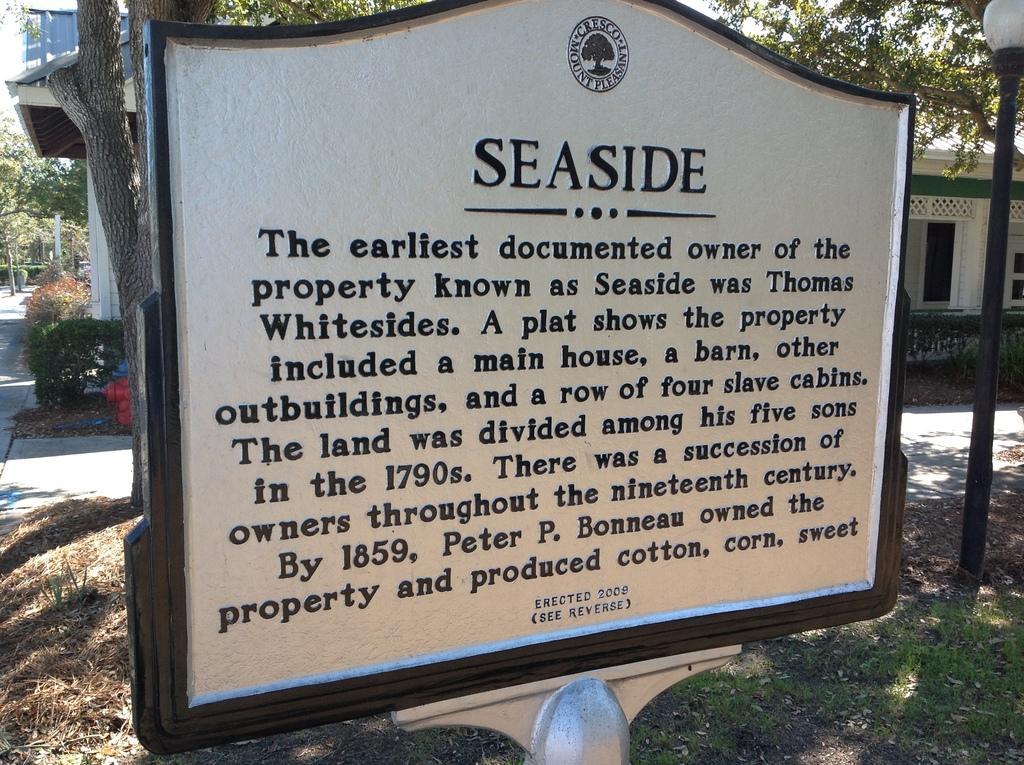In one or two sentences, can you explain what this image depicts? In this image, I can see a board with a text. In the background, there are trees, plants and a house. On the right side of the image, I can see a light pole. 